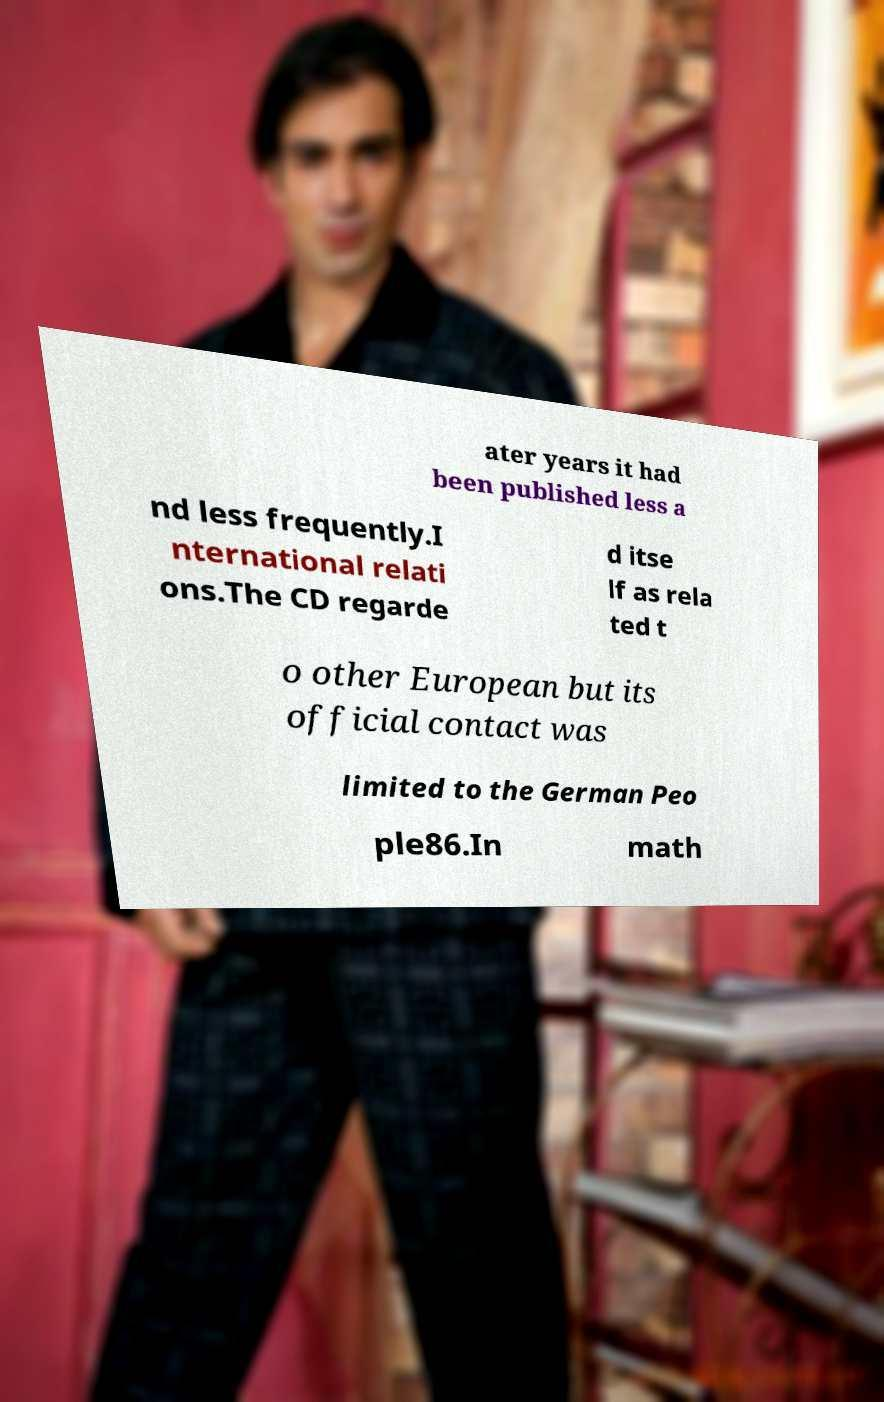Could you assist in decoding the text presented in this image and type it out clearly? ater years it had been published less a nd less frequently.I nternational relati ons.The CD regarde d itse lf as rela ted t o other European but its official contact was limited to the German Peo ple86.In math 